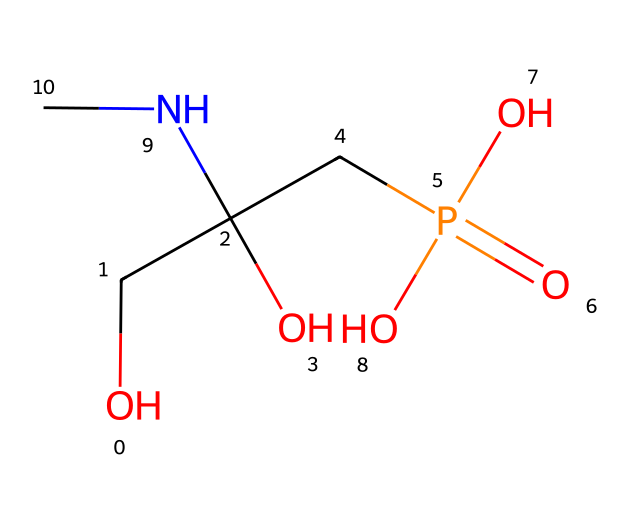What is the molecular formula of glyphosate? By analyzing the SMILES representation, we can identify the constituent atoms. Counting the atoms gives us C3, H6, N1, O4, and P1. This combines to form the molecular formula C3H6N1O4P1.
Answer: C3H6N1O4P1 How many chiral centers are present in glyphosate? Chiral centers are typically associated with carbon atoms that are bonded to four different substituents. In the SMILES representation, we can see that there is one carbon atom (the central carbon) that meets this criterion, indicating one chiral center.
Answer: 1 What functional groups are present in glyphosate? The SMILES representation contains several functional groups: a hydroxyl group (-OH), an amine group (-NH), a phosphate group (-PO4), and carboxylic acid (-COOH). Together, these groups define the reactivity of glyphosate.
Answer: Hydroxyl, amine, phosphate, carboxylic acid What is the total number of oxygen atoms in glyphosate? By examining the structure through the SMILES representation, we observe multiple instances of oxygen, specifically within functional groups such as the hydroxyl and phosphate groups. Counting yields a total of four oxygen atoms.
Answer: 4 What type of chemical compound is glyphosate classified as? Glyphosate contains a phosphate group and is used to inhibit the shikimic acid pathway in plants, which is key for its classification. This indicates it is an herbicide, specifically a systemic herbicide.
Answer: Herbicide Which atom in glyphosate contributes to its acidity? The carboxylic acid functional group contains a carbon atom bonded to an -OH group, which can donate a proton (H+) making it acidic. This is usually the part responsible for the acidity in organic compounds.
Answer: Carbon of carboxylic acid 